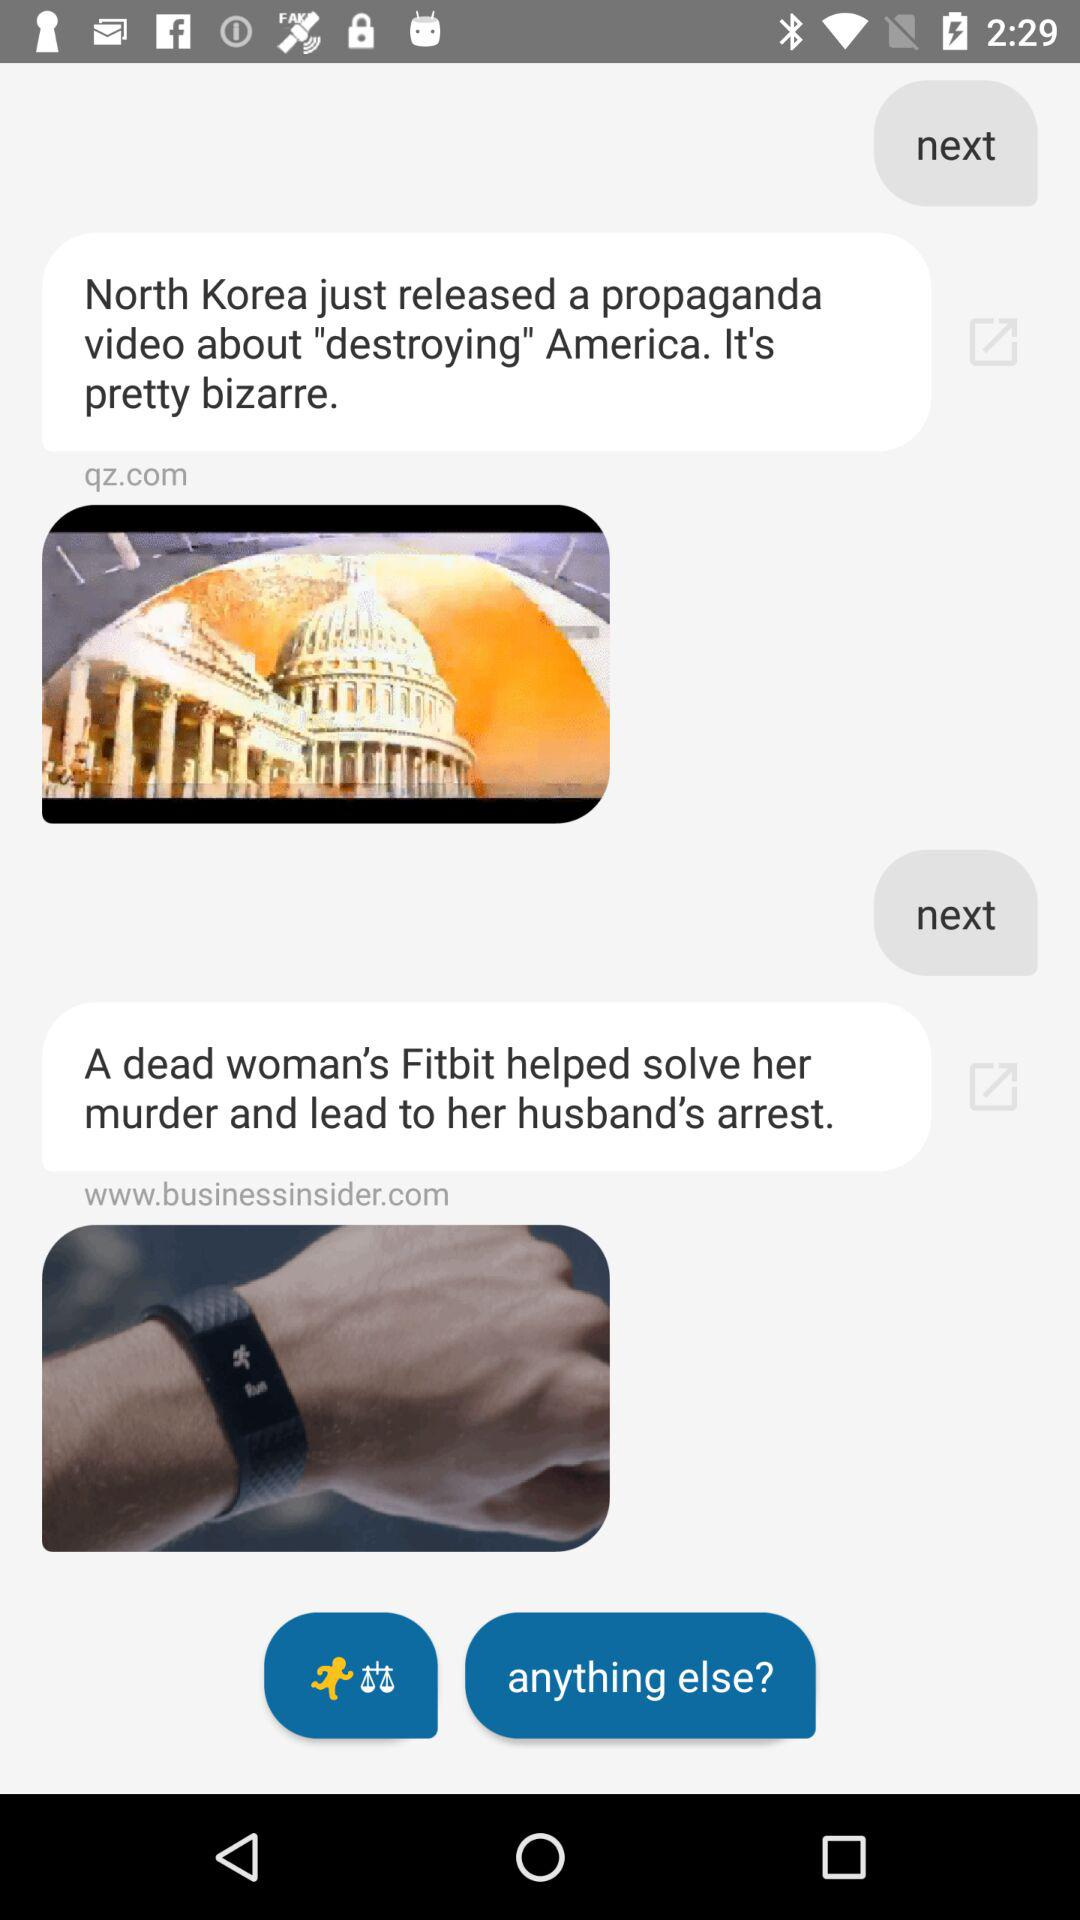Which website was used to share the news about North Korea? The website that was used to share the news about North Korea is qz.com. 